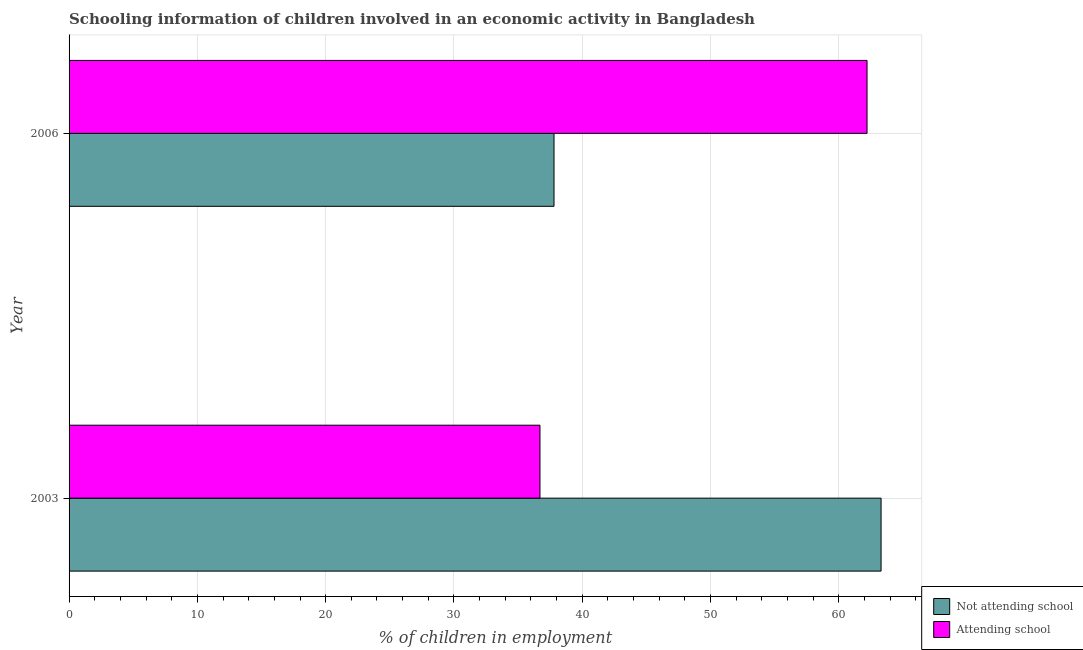Are the number of bars per tick equal to the number of legend labels?
Provide a short and direct response. Yes. How many bars are there on the 2nd tick from the bottom?
Your response must be concise. 2. What is the label of the 2nd group of bars from the top?
Your answer should be compact. 2003. What is the percentage of employed children who are attending school in 2006?
Your response must be concise. 62.2. Across all years, what is the maximum percentage of employed children who are not attending school?
Offer a terse response. 63.29. Across all years, what is the minimum percentage of employed children who are not attending school?
Your answer should be compact. 37.8. What is the total percentage of employed children who are attending school in the graph?
Your answer should be very brief. 98.91. What is the difference between the percentage of employed children who are not attending school in 2003 and that in 2006?
Your answer should be compact. 25.49. What is the difference between the percentage of employed children who are not attending school in 2003 and the percentage of employed children who are attending school in 2006?
Make the answer very short. 1.09. What is the average percentage of employed children who are attending school per year?
Provide a short and direct response. 49.45. In the year 2003, what is the difference between the percentage of employed children who are attending school and percentage of employed children who are not attending school?
Your answer should be compact. -26.59. In how many years, is the percentage of employed children who are not attending school greater than 26 %?
Provide a succinct answer. 2. What is the ratio of the percentage of employed children who are attending school in 2003 to that in 2006?
Your answer should be compact. 0.59. Is the percentage of employed children who are not attending school in 2003 less than that in 2006?
Offer a very short reply. No. What does the 2nd bar from the top in 2003 represents?
Provide a succinct answer. Not attending school. What does the 2nd bar from the bottom in 2003 represents?
Offer a very short reply. Attending school. How many years are there in the graph?
Provide a short and direct response. 2. What is the difference between two consecutive major ticks on the X-axis?
Offer a very short reply. 10. Are the values on the major ticks of X-axis written in scientific E-notation?
Give a very brief answer. No. How are the legend labels stacked?
Ensure brevity in your answer.  Vertical. What is the title of the graph?
Your response must be concise. Schooling information of children involved in an economic activity in Bangladesh. Does "By country of origin" appear as one of the legend labels in the graph?
Make the answer very short. No. What is the label or title of the X-axis?
Ensure brevity in your answer.  % of children in employment. What is the % of children in employment in Not attending school in 2003?
Offer a terse response. 63.29. What is the % of children in employment of Attending school in 2003?
Ensure brevity in your answer.  36.71. What is the % of children in employment in Not attending school in 2006?
Provide a short and direct response. 37.8. What is the % of children in employment in Attending school in 2006?
Give a very brief answer. 62.2. Across all years, what is the maximum % of children in employment in Not attending school?
Your answer should be compact. 63.29. Across all years, what is the maximum % of children in employment of Attending school?
Provide a short and direct response. 62.2. Across all years, what is the minimum % of children in employment of Not attending school?
Your response must be concise. 37.8. Across all years, what is the minimum % of children in employment in Attending school?
Your answer should be very brief. 36.71. What is the total % of children in employment of Not attending school in the graph?
Provide a succinct answer. 101.09. What is the total % of children in employment in Attending school in the graph?
Offer a terse response. 98.91. What is the difference between the % of children in employment in Not attending school in 2003 and that in 2006?
Offer a terse response. 25.49. What is the difference between the % of children in employment in Attending school in 2003 and that in 2006?
Provide a succinct answer. -25.49. What is the difference between the % of children in employment in Not attending school in 2003 and the % of children in employment in Attending school in 2006?
Offer a very short reply. 1.09. What is the average % of children in employment in Not attending school per year?
Your response must be concise. 50.55. What is the average % of children in employment of Attending school per year?
Provide a succinct answer. 49.45. In the year 2003, what is the difference between the % of children in employment in Not attending school and % of children in employment in Attending school?
Make the answer very short. 26.59. In the year 2006, what is the difference between the % of children in employment in Not attending school and % of children in employment in Attending school?
Offer a terse response. -24.4. What is the ratio of the % of children in employment of Not attending school in 2003 to that in 2006?
Offer a terse response. 1.67. What is the ratio of the % of children in employment in Attending school in 2003 to that in 2006?
Offer a terse response. 0.59. What is the difference between the highest and the second highest % of children in employment of Not attending school?
Provide a short and direct response. 25.49. What is the difference between the highest and the second highest % of children in employment of Attending school?
Provide a short and direct response. 25.49. What is the difference between the highest and the lowest % of children in employment in Not attending school?
Make the answer very short. 25.49. What is the difference between the highest and the lowest % of children in employment in Attending school?
Give a very brief answer. 25.49. 